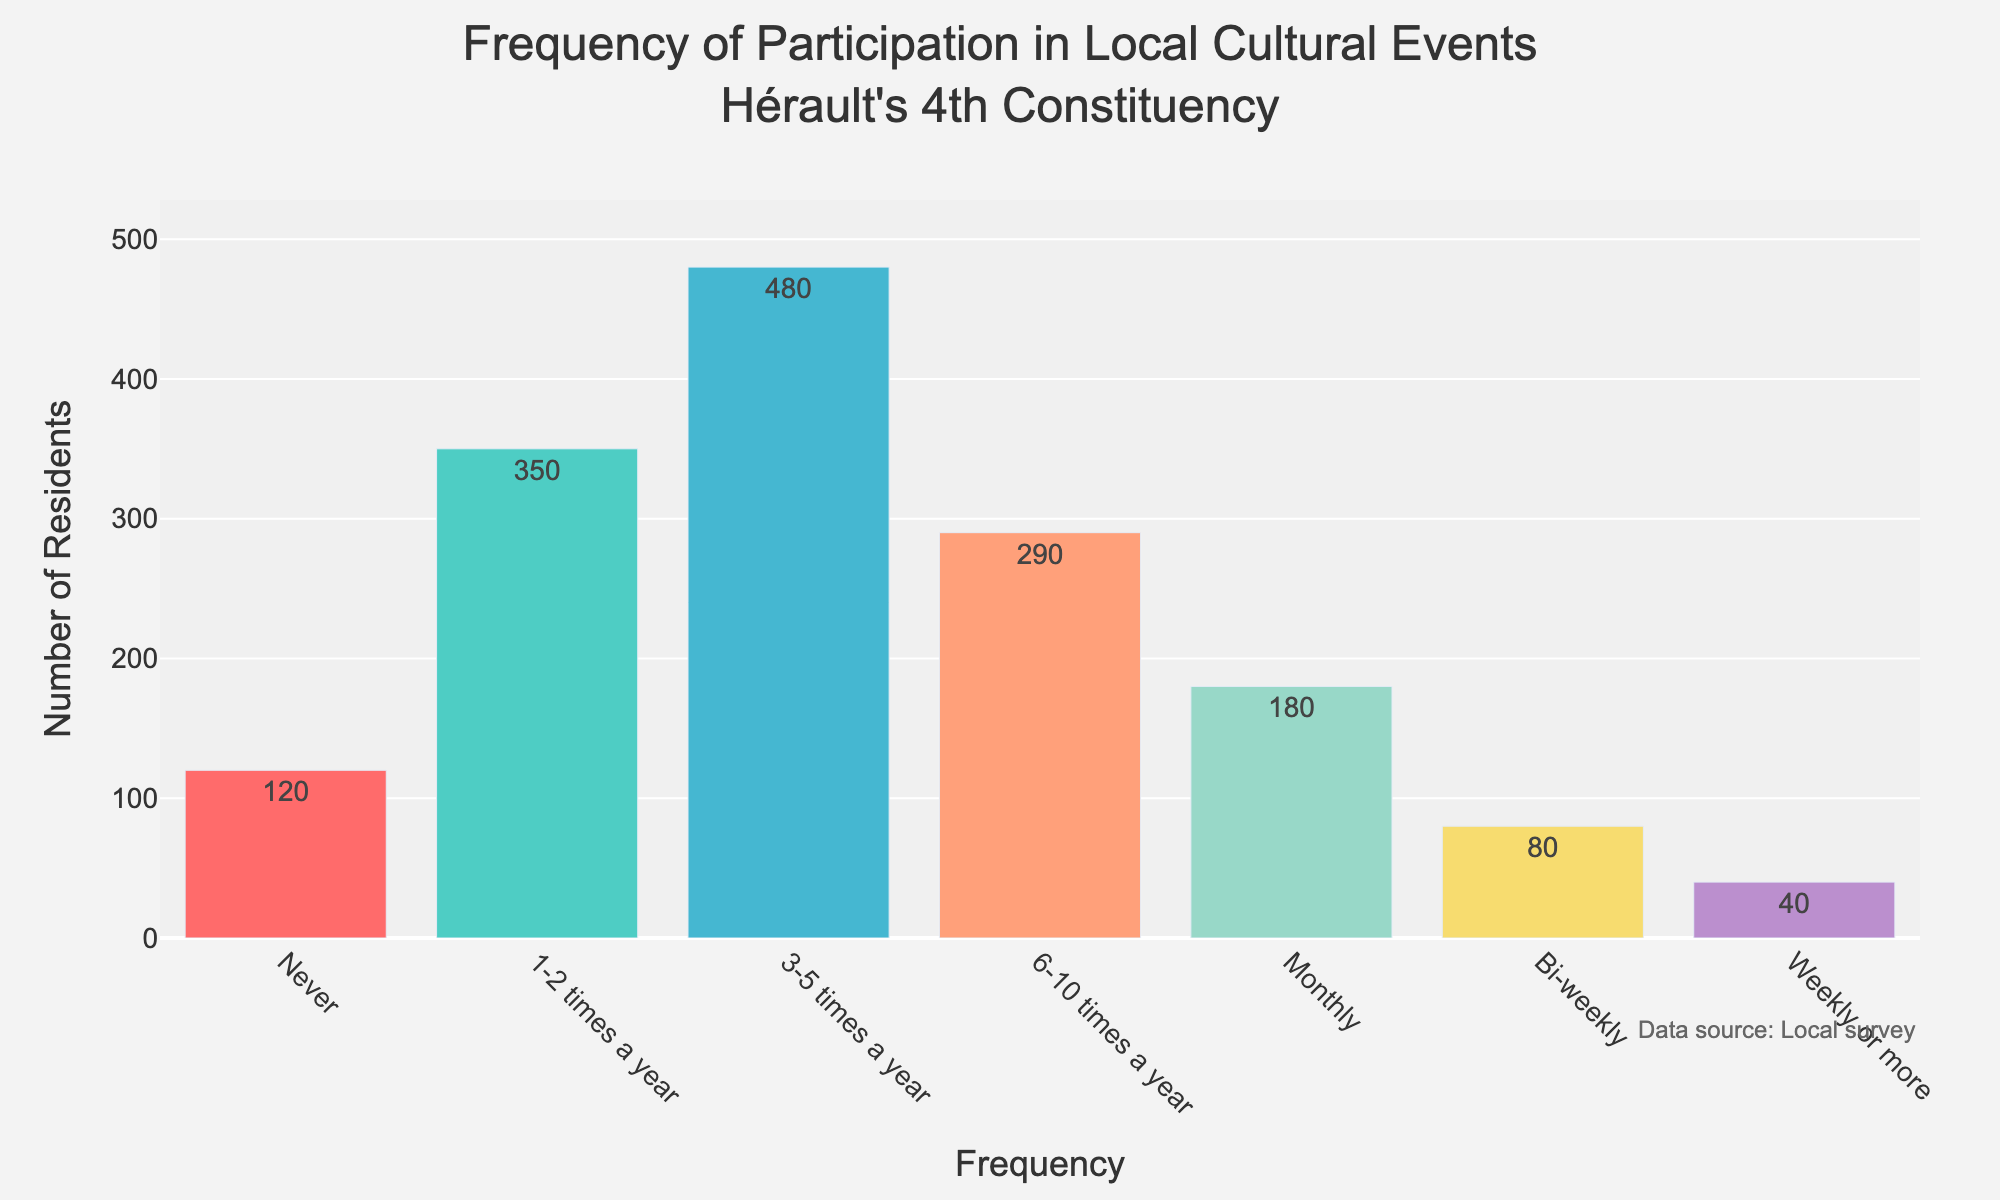What is the title of the histogram? The title is usually displayed prominently at the top of the figure. Here, it reads "Frequency of Participation in Local Cultural Events Hérault's 4th Constituency" indicating the data being represented.
Answer: Frequency of Participation in Local Cultural Events Hérault's 4th Constituency Which frequency category has the highest number of residents? By inspecting the height of the bars, the tallest bar corresponds to the "3-5 times a year" category, indicating it has the highest number of residents.
Answer: 3-5 times a year How many residents participate in cultural events weekly or more? The bar labeled "Weekly or more" shows the number of residents participating at this frequency. The text on the bar indicates there are 40 residents.
Answer: 40 What's the total number of residents who participate in cultural events monthly or more frequently? To find this, add the number of residents for "Monthly," "Bi-weekly," and "Weekly or more." Monthly has 180, Bi-weekly has 80, and Weekly or more has 40. So, 180 + 80 + 40 = 300.
Answer: 300 How does the number of residents who never participate compare to those who do so 1-2 times a year? Compare the height of the bars labeled "Never" and "1-2 times a year." The "Never" bar is shorter with 120 residents compared to the "1-2 times a year" bar with 350 residents.
Answer: 120 vs 350 Which color represents the "6-10 times a year" frequency category? Bars are color-coded, and the "6-10 times a year" bar corresponds to the medium pink/salmon color in the figure.
Answer: Pink/Salmon What is the sum of residents participating either 1-2 times a year or 6-10 times a year? Add the number of residents for "1-2 times a year" (350) and "6-10 times a year" (290). So, 350 + 290 = 640.
Answer: 640 What is the difference in participation between the "3-5 times a year" group and the "Never" group? Subtract the number of residents in the "Never" group from those in the "3-5 times a year" group. 480 - 120 = 360.
Answer: 360 What number of residents fall into the categories less frequent than monthly participation? Sum the residents for "Never," "1-2 times a year," "3-5 times a year," and "6-10 times a year." 120 + 350 + 480 + 290 = 1240.
Answer: 1240 What is the average number of residents across all participation frequencies? To find the average, sum all the residents and divide by the number of categories. 120 (Never) + 350 (1-2 times) + 480 (3-5 times) + 290 (6-10 times) + 180 (Monthly) + 80 (Bi-weekly) + 40 (Weekly or more) = 1540. Divide by 7 categories: 1540 / 7 ≈ 220.
Answer: 220 